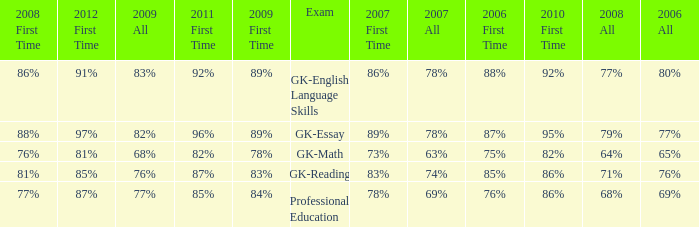What is the percentage for 2008 First time when in 2006 it was 85%? 81%. 